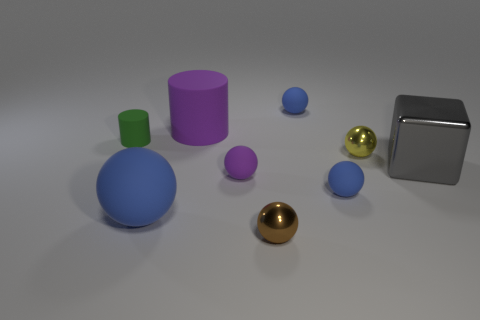Are there fewer small blue matte spheres than tiny green matte objects?
Your answer should be compact. No. What material is the object that is in front of the blue rubber ball that is left of the small metallic sphere that is in front of the big block?
Make the answer very short. Metal. What material is the big cube?
Offer a terse response. Metal. Is the color of the metallic cube to the right of the tiny brown metal sphere the same as the tiny metal thing that is in front of the yellow metal object?
Offer a terse response. No. Is the number of matte spheres greater than the number of blue matte things?
Offer a very short reply. Yes. How many other spheres are the same color as the big rubber sphere?
Offer a terse response. 2. There is another big object that is the same shape as the brown metal thing; what is its color?
Keep it short and to the point. Blue. What is the small sphere that is behind the large shiny block and to the left of the tiny yellow ball made of?
Your response must be concise. Rubber. Are the tiny blue ball that is behind the green rubber object and the big thing that is in front of the tiny purple object made of the same material?
Your response must be concise. Yes. What size is the brown metal object?
Offer a very short reply. Small. 